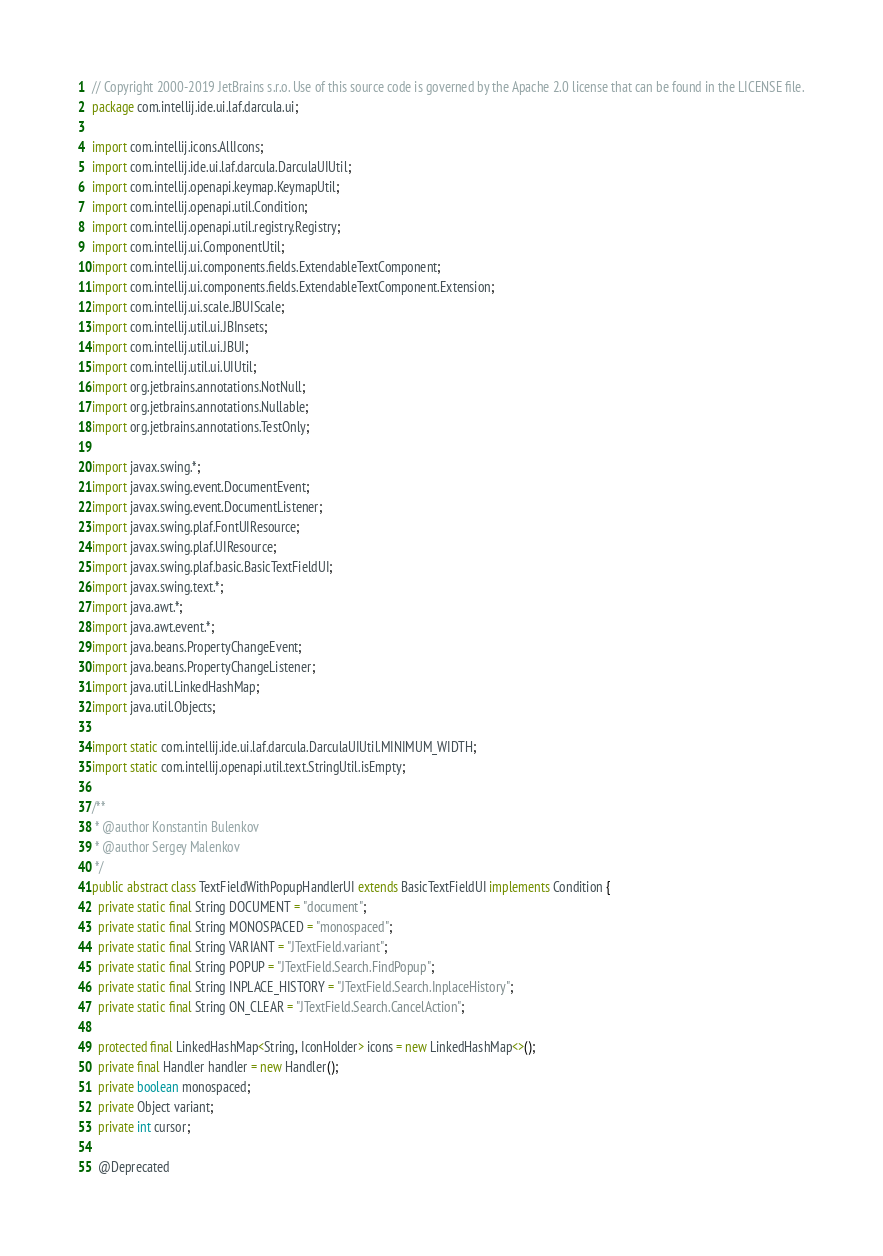<code> <loc_0><loc_0><loc_500><loc_500><_Java_>// Copyright 2000-2019 JetBrains s.r.o. Use of this source code is governed by the Apache 2.0 license that can be found in the LICENSE file.
package com.intellij.ide.ui.laf.darcula.ui;

import com.intellij.icons.AllIcons;
import com.intellij.ide.ui.laf.darcula.DarculaUIUtil;
import com.intellij.openapi.keymap.KeymapUtil;
import com.intellij.openapi.util.Condition;
import com.intellij.openapi.util.registry.Registry;
import com.intellij.ui.ComponentUtil;
import com.intellij.ui.components.fields.ExtendableTextComponent;
import com.intellij.ui.components.fields.ExtendableTextComponent.Extension;
import com.intellij.ui.scale.JBUIScale;
import com.intellij.util.ui.JBInsets;
import com.intellij.util.ui.JBUI;
import com.intellij.util.ui.UIUtil;
import org.jetbrains.annotations.NotNull;
import org.jetbrains.annotations.Nullable;
import org.jetbrains.annotations.TestOnly;

import javax.swing.*;
import javax.swing.event.DocumentEvent;
import javax.swing.event.DocumentListener;
import javax.swing.plaf.FontUIResource;
import javax.swing.plaf.UIResource;
import javax.swing.plaf.basic.BasicTextFieldUI;
import javax.swing.text.*;
import java.awt.*;
import java.awt.event.*;
import java.beans.PropertyChangeEvent;
import java.beans.PropertyChangeListener;
import java.util.LinkedHashMap;
import java.util.Objects;

import static com.intellij.ide.ui.laf.darcula.DarculaUIUtil.MINIMUM_WIDTH;
import static com.intellij.openapi.util.text.StringUtil.isEmpty;

/**
 * @author Konstantin Bulenkov
 * @author Sergey Malenkov
 */
public abstract class TextFieldWithPopupHandlerUI extends BasicTextFieldUI implements Condition {
  private static final String DOCUMENT = "document";
  private static final String MONOSPACED = "monospaced";
  private static final String VARIANT = "JTextField.variant";
  private static final String POPUP = "JTextField.Search.FindPopup";
  private static final String INPLACE_HISTORY = "JTextField.Search.InplaceHistory";
  private static final String ON_CLEAR = "JTextField.Search.CancelAction";

  protected final LinkedHashMap<String, IconHolder> icons = new LinkedHashMap<>();
  private final Handler handler = new Handler();
  private boolean monospaced;
  private Object variant;
  private int cursor;

  @Deprecated</code> 